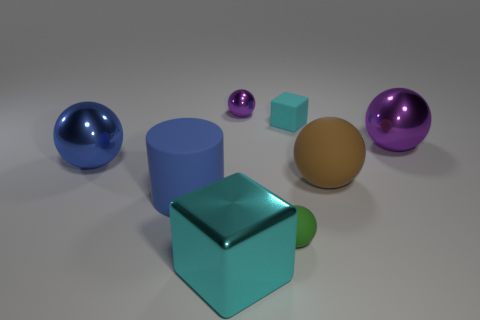Subtract all purple cylinders. How many purple balls are left? 2 Subtract all blue metallic spheres. How many spheres are left? 4 Add 1 big cyan objects. How many objects exist? 9 Subtract all brown spheres. How many spheres are left? 4 Subtract all blocks. How many objects are left? 6 Subtract all yellow balls. Subtract all blue cubes. How many balls are left? 5 Subtract all tiny cyan balls. Subtract all metallic cubes. How many objects are left? 7 Add 7 rubber cylinders. How many rubber cylinders are left? 8 Add 6 large green matte balls. How many large green matte balls exist? 6 Subtract 1 green spheres. How many objects are left? 7 